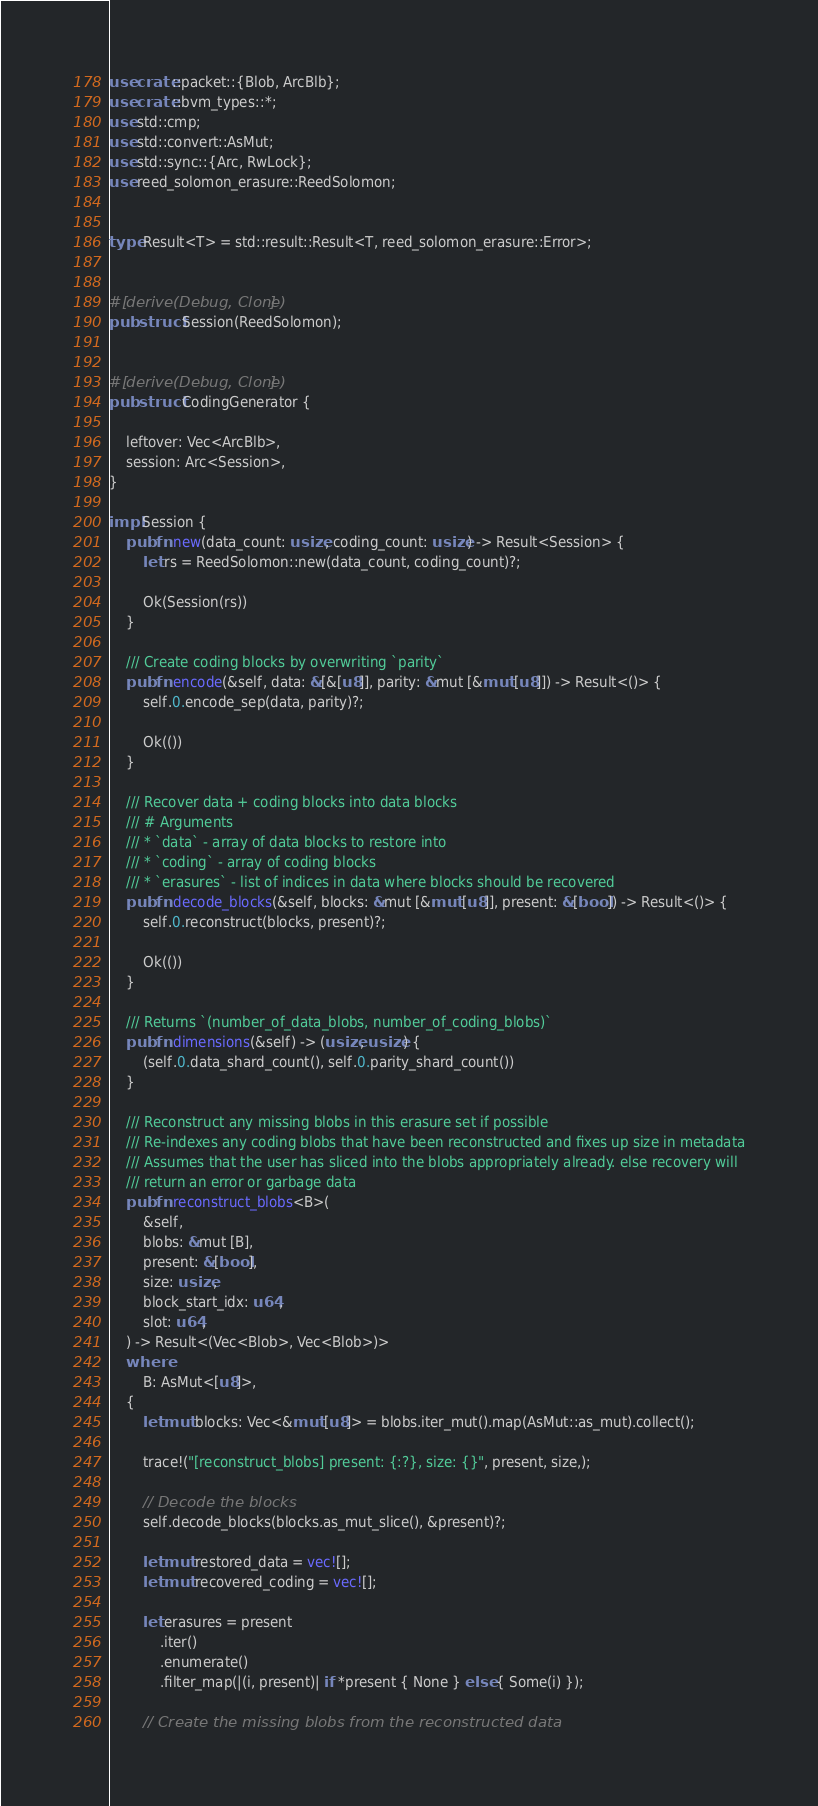Convert code to text. <code><loc_0><loc_0><loc_500><loc_500><_Rust_>use crate::packet::{Blob, ArcBlb};
use crate::bvm_types::*;
use std::cmp;
use std::convert::AsMut;
use std::sync::{Arc, RwLock};
use reed_solomon_erasure::ReedSolomon;


type Result<T> = std::result::Result<T, reed_solomon_erasure::Error>;


#[derive(Debug, Clone)]
pub struct Session(ReedSolomon);


#[derive(Debug, Clone)]
pub struct CodingGenerator {
   
    leftover: Vec<ArcBlb>,
    session: Arc<Session>,
}

impl Session {
    pub fn new(data_count: usize, coding_count: usize) -> Result<Session> {
        let rs = ReedSolomon::new(data_count, coding_count)?;

        Ok(Session(rs))
    }

    /// Create coding blocks by overwriting `parity`
    pub fn encode(&self, data: &[&[u8]], parity: &mut [&mut [u8]]) -> Result<()> {
        self.0.encode_sep(data, parity)?;

        Ok(())
    }

    /// Recover data + coding blocks into data blocks
    /// # Arguments
    /// * `data` - array of data blocks to restore into
    /// * `coding` - array of coding blocks
    /// * `erasures` - list of indices in data where blocks should be recovered
    pub fn decode_blocks(&self, blocks: &mut [&mut [u8]], present: &[bool]) -> Result<()> {
        self.0.reconstruct(blocks, present)?;

        Ok(())
    }

    /// Returns `(number_of_data_blobs, number_of_coding_blobs)`
    pub fn dimensions(&self) -> (usize, usize) {
        (self.0.data_shard_count(), self.0.parity_shard_count())
    }

    /// Reconstruct any missing blobs in this erasure set if possible
    /// Re-indexes any coding blobs that have been reconstructed and fixes up size in metadata
    /// Assumes that the user has sliced into the blobs appropriately already. else recovery will
    /// return an error or garbage data
    pub fn reconstruct_blobs<B>(
        &self,
        blobs: &mut [B],
        present: &[bool],
        size: usize,
        block_start_idx: u64,
        slot: u64,
    ) -> Result<(Vec<Blob>, Vec<Blob>)>
    where
        B: AsMut<[u8]>,
    {
        let mut blocks: Vec<&mut [u8]> = blobs.iter_mut().map(AsMut::as_mut).collect();

        trace!("[reconstruct_blobs] present: {:?}, size: {}", present, size,);

        // Decode the blocks
        self.decode_blocks(blocks.as_mut_slice(), &present)?;

        let mut restored_data = vec![];
        let mut recovered_coding = vec![];

        let erasures = present
            .iter()
            .enumerate()
            .filter_map(|(i, present)| if *present { None } else { Some(i) });

        // Create the missing blobs from the reconstructed data</code> 